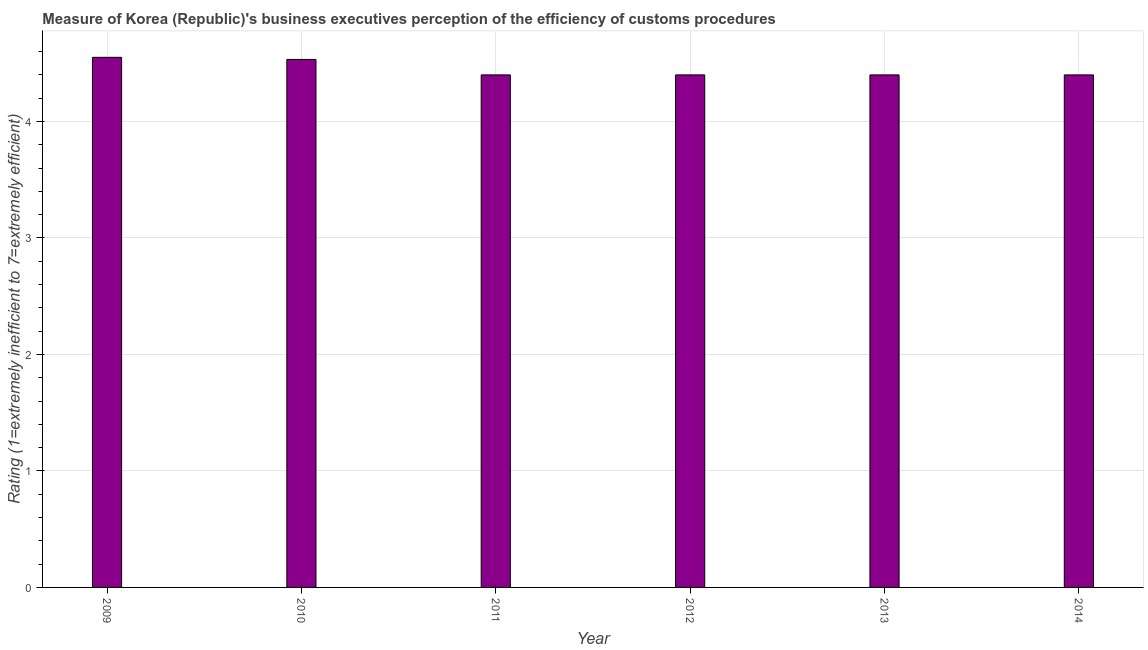Does the graph contain any zero values?
Ensure brevity in your answer.  No. What is the title of the graph?
Your answer should be very brief. Measure of Korea (Republic)'s business executives perception of the efficiency of customs procedures. What is the label or title of the Y-axis?
Offer a very short reply. Rating (1=extremely inefficient to 7=extremely efficient). Across all years, what is the maximum rating measuring burden of customs procedure?
Keep it short and to the point. 4.55. What is the sum of the rating measuring burden of customs procedure?
Make the answer very short. 26.68. What is the average rating measuring burden of customs procedure per year?
Provide a succinct answer. 4.45. In how many years, is the rating measuring burden of customs procedure greater than 1.8 ?
Your answer should be very brief. 6. What is the difference between the highest and the second highest rating measuring burden of customs procedure?
Give a very brief answer. 0.02. What is the difference between two consecutive major ticks on the Y-axis?
Give a very brief answer. 1. What is the Rating (1=extremely inefficient to 7=extremely efficient) in 2009?
Your response must be concise. 4.55. What is the Rating (1=extremely inefficient to 7=extremely efficient) of 2010?
Provide a short and direct response. 4.53. What is the Rating (1=extremely inefficient to 7=extremely efficient) of 2011?
Give a very brief answer. 4.4. What is the difference between the Rating (1=extremely inefficient to 7=extremely efficient) in 2009 and 2010?
Offer a terse response. 0.02. What is the difference between the Rating (1=extremely inefficient to 7=extremely efficient) in 2009 and 2011?
Make the answer very short. 0.15. What is the difference between the Rating (1=extremely inefficient to 7=extremely efficient) in 2009 and 2012?
Give a very brief answer. 0.15. What is the difference between the Rating (1=extremely inefficient to 7=extremely efficient) in 2009 and 2013?
Your answer should be compact. 0.15. What is the difference between the Rating (1=extremely inefficient to 7=extremely efficient) in 2009 and 2014?
Provide a short and direct response. 0.15. What is the difference between the Rating (1=extremely inefficient to 7=extremely efficient) in 2010 and 2011?
Give a very brief answer. 0.13. What is the difference between the Rating (1=extremely inefficient to 7=extremely efficient) in 2010 and 2012?
Your response must be concise. 0.13. What is the difference between the Rating (1=extremely inefficient to 7=extremely efficient) in 2010 and 2013?
Offer a very short reply. 0.13. What is the difference between the Rating (1=extremely inefficient to 7=extremely efficient) in 2010 and 2014?
Ensure brevity in your answer.  0.13. What is the difference between the Rating (1=extremely inefficient to 7=extremely efficient) in 2011 and 2012?
Provide a succinct answer. 0. What is the difference between the Rating (1=extremely inefficient to 7=extremely efficient) in 2011 and 2014?
Provide a short and direct response. 0. What is the ratio of the Rating (1=extremely inefficient to 7=extremely efficient) in 2009 to that in 2010?
Your answer should be very brief. 1. What is the ratio of the Rating (1=extremely inefficient to 7=extremely efficient) in 2009 to that in 2011?
Your response must be concise. 1.03. What is the ratio of the Rating (1=extremely inefficient to 7=extremely efficient) in 2009 to that in 2012?
Your answer should be very brief. 1.03. What is the ratio of the Rating (1=extremely inefficient to 7=extremely efficient) in 2009 to that in 2013?
Your answer should be very brief. 1.03. What is the ratio of the Rating (1=extremely inefficient to 7=extremely efficient) in 2009 to that in 2014?
Ensure brevity in your answer.  1.03. What is the ratio of the Rating (1=extremely inefficient to 7=extremely efficient) in 2010 to that in 2011?
Give a very brief answer. 1.03. What is the ratio of the Rating (1=extremely inefficient to 7=extremely efficient) in 2011 to that in 2013?
Your answer should be compact. 1. What is the ratio of the Rating (1=extremely inefficient to 7=extremely efficient) in 2011 to that in 2014?
Provide a succinct answer. 1. What is the ratio of the Rating (1=extremely inefficient to 7=extremely efficient) in 2012 to that in 2013?
Give a very brief answer. 1. What is the ratio of the Rating (1=extremely inefficient to 7=extremely efficient) in 2012 to that in 2014?
Ensure brevity in your answer.  1. 